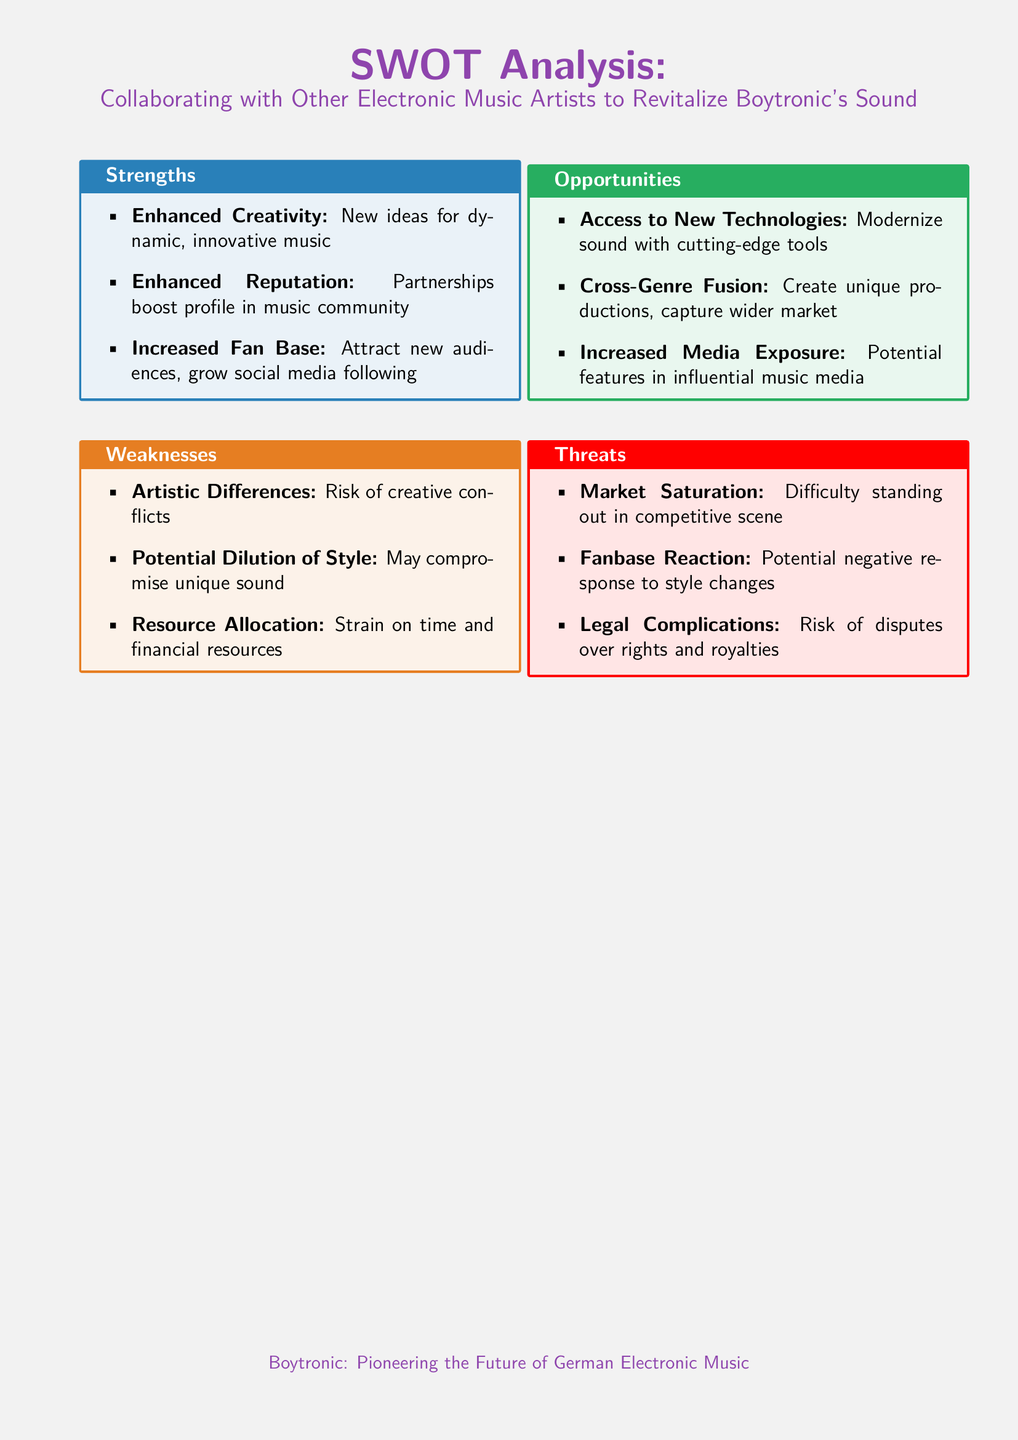What are the strengths in the SWOT analysis? The strengths listed in the SWOT analysis include enhanced creativity, enhanced reputation, and increased fan base.
Answer: Enhanced creativity, enhanced reputation, increased fan base What could be a potential weakness when collaborating? A weakness mentioned is the risk of creative conflicts that may arise from collaboration.
Answer: Risk of creative conflicts What opportunity does the SWOT analysis mention related to technology? The analysis highlights access to new technologies as an opportunity for modernizing sound.
Answer: Access to new technologies What is a threat concerning market competition? Market saturation is noted as a threat that could affect the success of Boytronic's collaborations.
Answer: Market saturation What does the document say about potential media exposure? The SWOT analysis mentions increased media exposure as an opportunity for Boytronic.
Answer: Increased media exposure How many weaknesses are identified in the document? The document lists three weaknesses related to collaboration.
Answer: Three What is the main purpose of the SWOT analysis? The main purpose is to evaluate the potential benefits and risks of collaborating with other electronic music artists to revitalize Boytronic's sound.
Answer: Evaluate potential benefits and risks What color is associated with the strengths section? The color used for the strengths section is synthblue.
Answer: Synthblue 